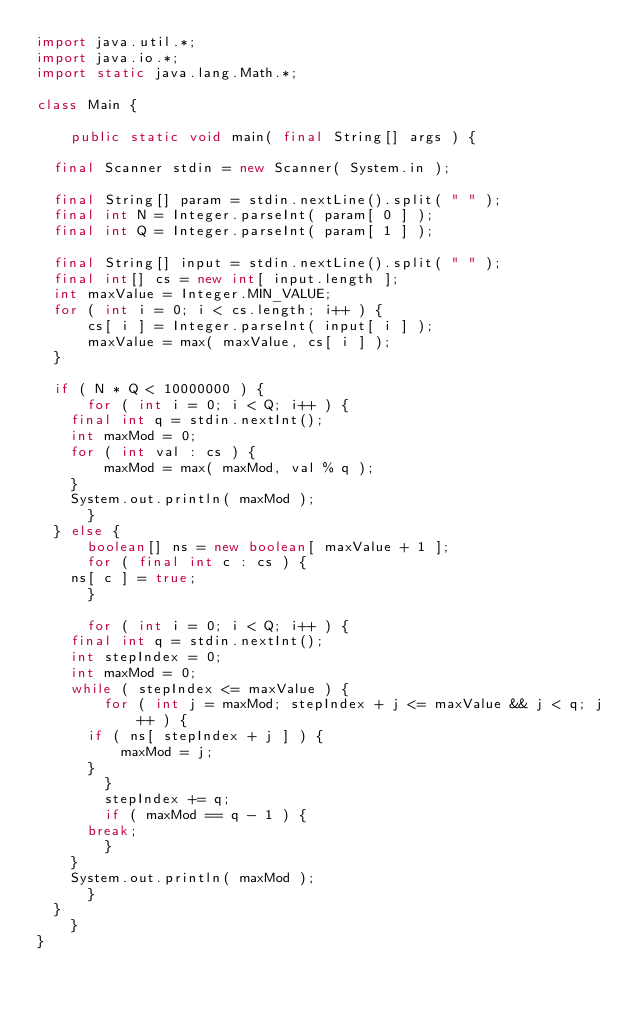<code> <loc_0><loc_0><loc_500><loc_500><_Java_>import java.util.*;
import java.io.*;
import static java.lang.Math.*;

class Main {

    public static void main( final String[] args ) {

	final Scanner stdin = new Scanner( System.in );

	final String[] param = stdin.nextLine().split( " " );
	final int N = Integer.parseInt( param[ 0 ] );
	final int Q = Integer.parseInt( param[ 1 ] );

	final String[] input = stdin.nextLine().split( " " );
	final int[] cs = new int[ input.length ];
	int maxValue = Integer.MIN_VALUE;
	for ( int i = 0; i < cs.length; i++ ) {
	    cs[ i ] = Integer.parseInt( input[ i ] );
	    maxValue = max( maxValue, cs[ i ] );
	}

	if ( N * Q < 10000000 ) {
	    for ( int i = 0; i < Q; i++ ) {
		final int q = stdin.nextInt();
		int maxMod = 0;
		for ( int val : cs ) {
		    maxMod = max( maxMod, val % q );
		}
		System.out.println( maxMod );
	    }
	} else {
	    boolean[] ns = new boolean[ maxValue + 1 ];
	    for ( final int c : cs ) {
		ns[ c ] = true;		
	    }
	    
	    for ( int i = 0; i < Q; i++ ) {
		final int q = stdin.nextInt();
		int stepIndex = 0;
		int maxMod = 0;
		while ( stepIndex <= maxValue ) {
		    for ( int j = maxMod; stepIndex + j <= maxValue && j < q; j++ ) {
			if ( ns[ stepIndex + j ] ) {
			    maxMod = j;
			}
		    }
		    stepIndex += q;
		    if ( maxMod == q - 1 ) {
			break;
		    }
		}
		System.out.println( maxMod );
	    }	
	}
    }
}</code> 